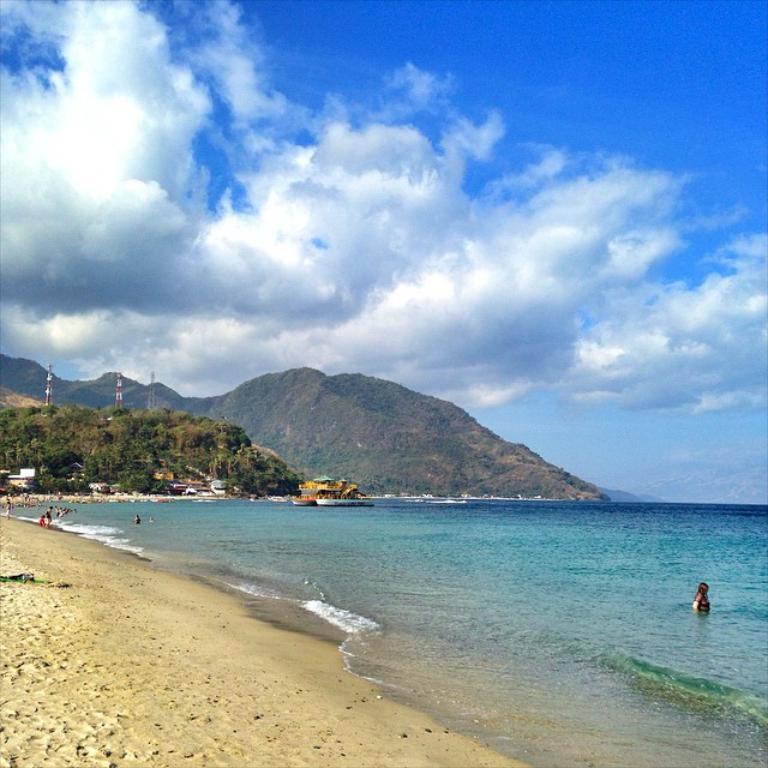Describe this image in one or two sentences. In the bottom right corner there is a woman who is in the water. On the left we can see many peoples were standing on the beach. In the center we can see many boats on the water. In the background we can see the mountains and trees. At the top there is a sky and clouds. At the top of the mountain there are three towers. 